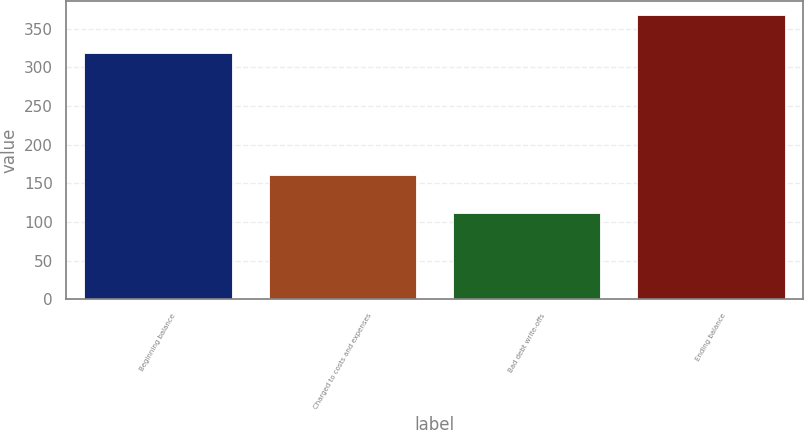Convert chart. <chart><loc_0><loc_0><loc_500><loc_500><bar_chart><fcel>Beginning balance<fcel>Charged to costs and expenses<fcel>Bad debt write-offs<fcel>Ending balance<nl><fcel>318<fcel>161<fcel>112<fcel>367<nl></chart> 